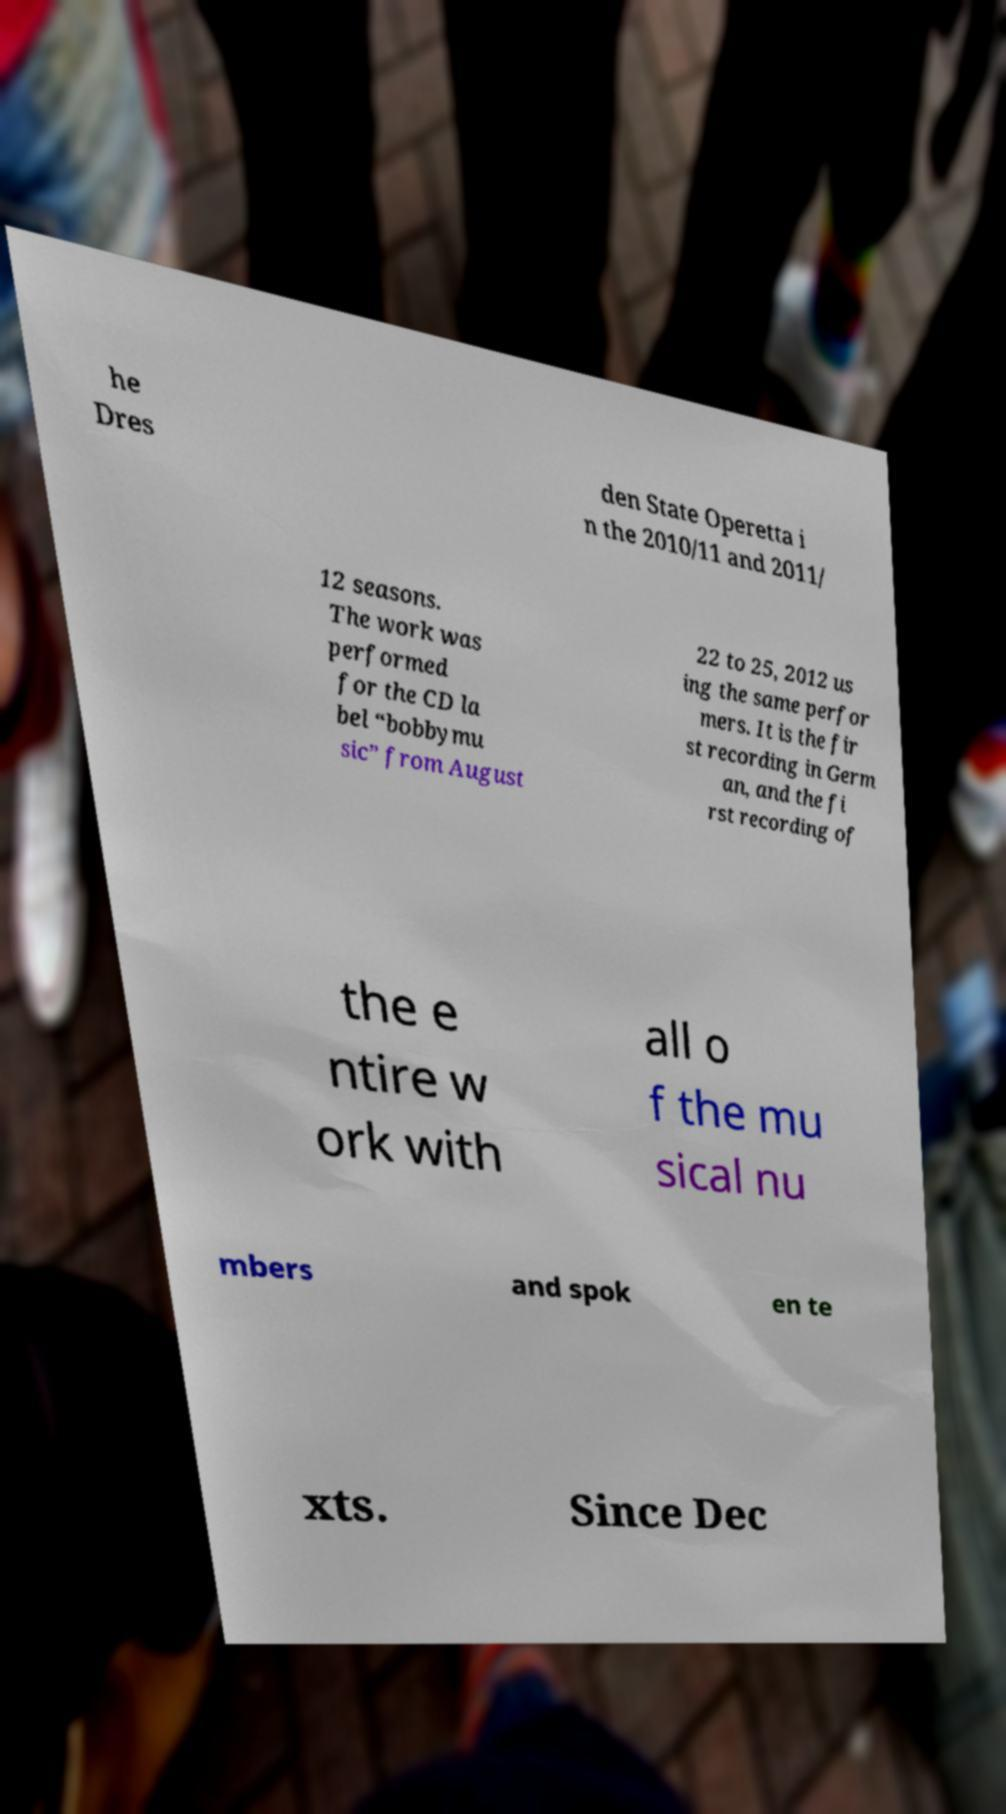Could you assist in decoding the text presented in this image and type it out clearly? he Dres den State Operetta i n the 2010/11 and 2011/ 12 seasons. The work was performed for the CD la bel “bobbymu sic” from August 22 to 25, 2012 us ing the same perfor mers. It is the fir st recording in Germ an, and the fi rst recording of the e ntire w ork with all o f the mu sical nu mbers and spok en te xts. Since Dec 